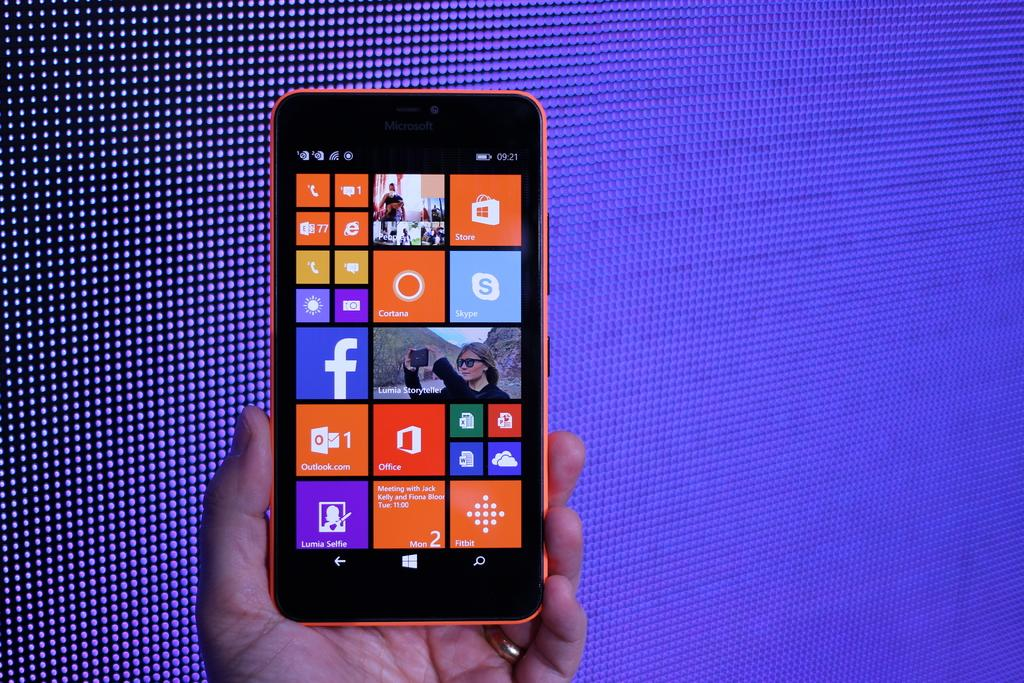<image>
Give a short and clear explanation of the subsequent image. A hand holding a windows phone with Skype and Facebook apps installed 